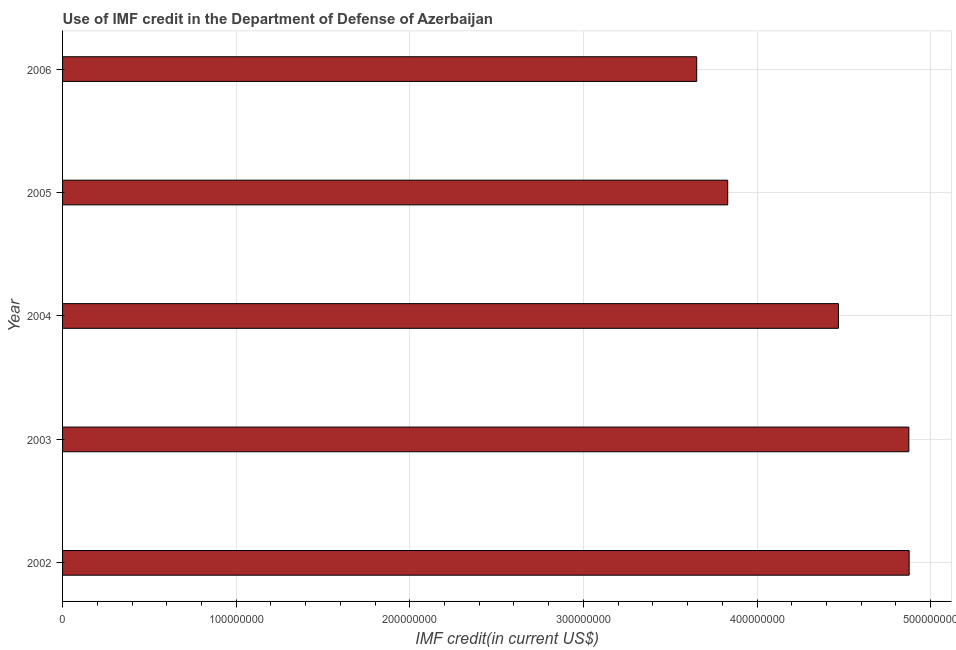Does the graph contain any zero values?
Your answer should be very brief. No. What is the title of the graph?
Give a very brief answer. Use of IMF credit in the Department of Defense of Azerbaijan. What is the label or title of the X-axis?
Your answer should be compact. IMF credit(in current US$). What is the label or title of the Y-axis?
Provide a succinct answer. Year. What is the use of imf credit in dod in 2006?
Your answer should be very brief. 3.65e+08. Across all years, what is the maximum use of imf credit in dod?
Give a very brief answer. 4.88e+08. Across all years, what is the minimum use of imf credit in dod?
Your answer should be very brief. 3.65e+08. What is the sum of the use of imf credit in dod?
Ensure brevity in your answer.  2.17e+09. What is the difference between the use of imf credit in dod in 2003 and 2004?
Offer a very short reply. 4.06e+07. What is the average use of imf credit in dod per year?
Your answer should be compact. 4.34e+08. What is the median use of imf credit in dod?
Offer a very short reply. 4.47e+08. In how many years, is the use of imf credit in dod greater than 280000000 US$?
Your response must be concise. 5. Do a majority of the years between 2003 and 2005 (inclusive) have use of imf credit in dod greater than 420000000 US$?
Keep it short and to the point. Yes. What is the ratio of the use of imf credit in dod in 2004 to that in 2005?
Your answer should be compact. 1.17. Is the use of imf credit in dod in 2002 less than that in 2005?
Offer a terse response. No. Is the difference between the use of imf credit in dod in 2002 and 2005 greater than the difference between any two years?
Your answer should be compact. No. What is the difference between the highest and the second highest use of imf credit in dod?
Ensure brevity in your answer.  1.80e+05. Is the sum of the use of imf credit in dod in 2002 and 2004 greater than the maximum use of imf credit in dod across all years?
Ensure brevity in your answer.  Yes. What is the difference between the highest and the lowest use of imf credit in dod?
Make the answer very short. 1.22e+08. How many bars are there?
Make the answer very short. 5. What is the difference between two consecutive major ticks on the X-axis?
Offer a terse response. 1.00e+08. Are the values on the major ticks of X-axis written in scientific E-notation?
Provide a short and direct response. No. What is the IMF credit(in current US$) of 2002?
Offer a very short reply. 4.88e+08. What is the IMF credit(in current US$) of 2003?
Make the answer very short. 4.87e+08. What is the IMF credit(in current US$) in 2004?
Ensure brevity in your answer.  4.47e+08. What is the IMF credit(in current US$) in 2005?
Ensure brevity in your answer.  3.83e+08. What is the IMF credit(in current US$) of 2006?
Offer a terse response. 3.65e+08. What is the difference between the IMF credit(in current US$) in 2002 and 2003?
Provide a succinct answer. 1.80e+05. What is the difference between the IMF credit(in current US$) in 2002 and 2004?
Your response must be concise. 4.08e+07. What is the difference between the IMF credit(in current US$) in 2002 and 2005?
Keep it short and to the point. 1.05e+08. What is the difference between the IMF credit(in current US$) in 2002 and 2006?
Offer a very short reply. 1.22e+08. What is the difference between the IMF credit(in current US$) in 2003 and 2004?
Give a very brief answer. 4.06e+07. What is the difference between the IMF credit(in current US$) in 2003 and 2005?
Provide a short and direct response. 1.04e+08. What is the difference between the IMF credit(in current US$) in 2003 and 2006?
Offer a very short reply. 1.22e+08. What is the difference between the IMF credit(in current US$) in 2004 and 2005?
Ensure brevity in your answer.  6.38e+07. What is the difference between the IMF credit(in current US$) in 2004 and 2006?
Provide a succinct answer. 8.16e+07. What is the difference between the IMF credit(in current US$) in 2005 and 2006?
Give a very brief answer. 1.79e+07. What is the ratio of the IMF credit(in current US$) in 2002 to that in 2003?
Provide a succinct answer. 1. What is the ratio of the IMF credit(in current US$) in 2002 to that in 2004?
Provide a succinct answer. 1.09. What is the ratio of the IMF credit(in current US$) in 2002 to that in 2005?
Your answer should be compact. 1.27. What is the ratio of the IMF credit(in current US$) in 2002 to that in 2006?
Make the answer very short. 1.33. What is the ratio of the IMF credit(in current US$) in 2003 to that in 2004?
Provide a succinct answer. 1.09. What is the ratio of the IMF credit(in current US$) in 2003 to that in 2005?
Make the answer very short. 1.27. What is the ratio of the IMF credit(in current US$) in 2003 to that in 2006?
Your answer should be compact. 1.33. What is the ratio of the IMF credit(in current US$) in 2004 to that in 2005?
Offer a terse response. 1.17. What is the ratio of the IMF credit(in current US$) in 2004 to that in 2006?
Your response must be concise. 1.22. What is the ratio of the IMF credit(in current US$) in 2005 to that in 2006?
Give a very brief answer. 1.05. 